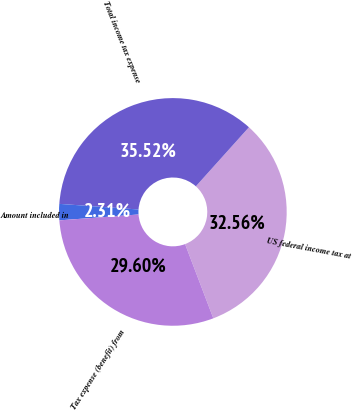Convert chart. <chart><loc_0><loc_0><loc_500><loc_500><pie_chart><fcel>US federal income tax at<fcel>Total income tax expense<fcel>Amount included in<fcel>Tax expense (benefit) from<nl><fcel>32.56%<fcel>35.52%<fcel>2.31%<fcel>29.6%<nl></chart> 